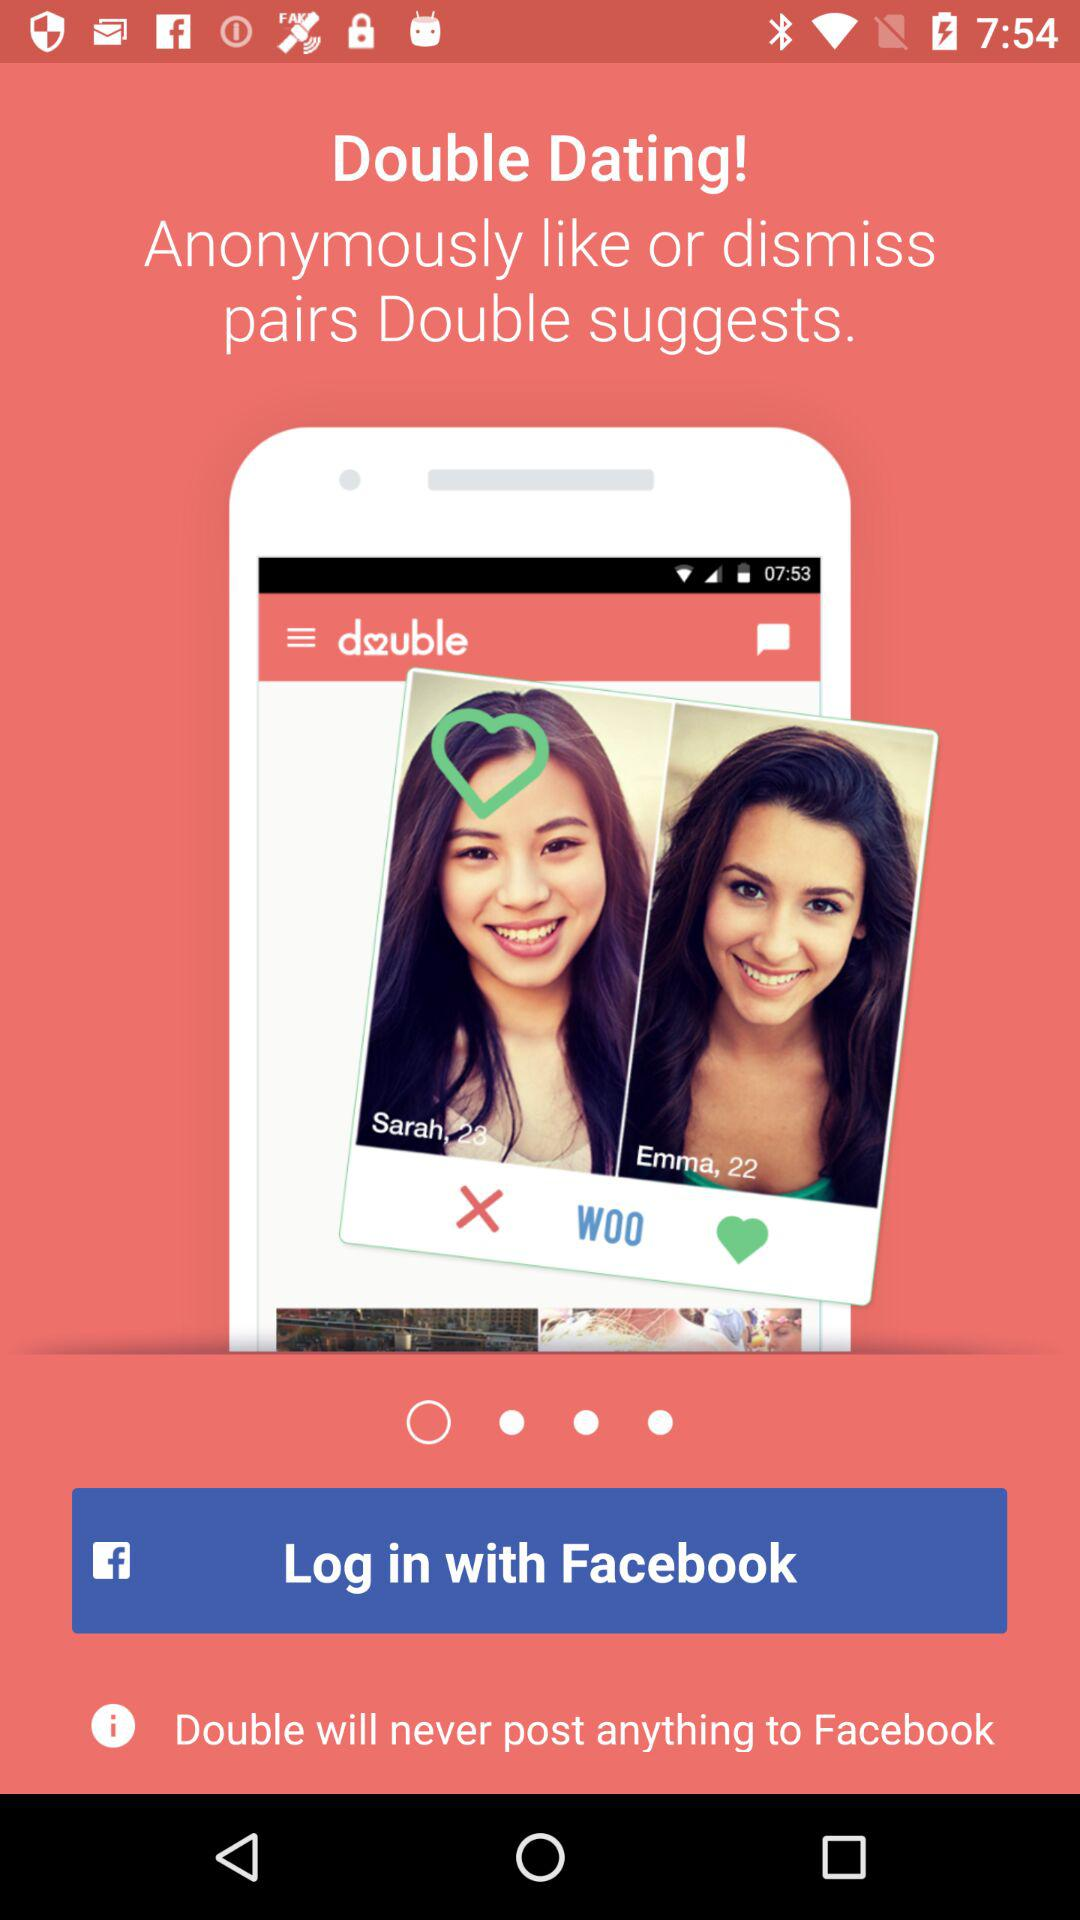What account can I use to log in? You can use the "Facebook" account to log in. 